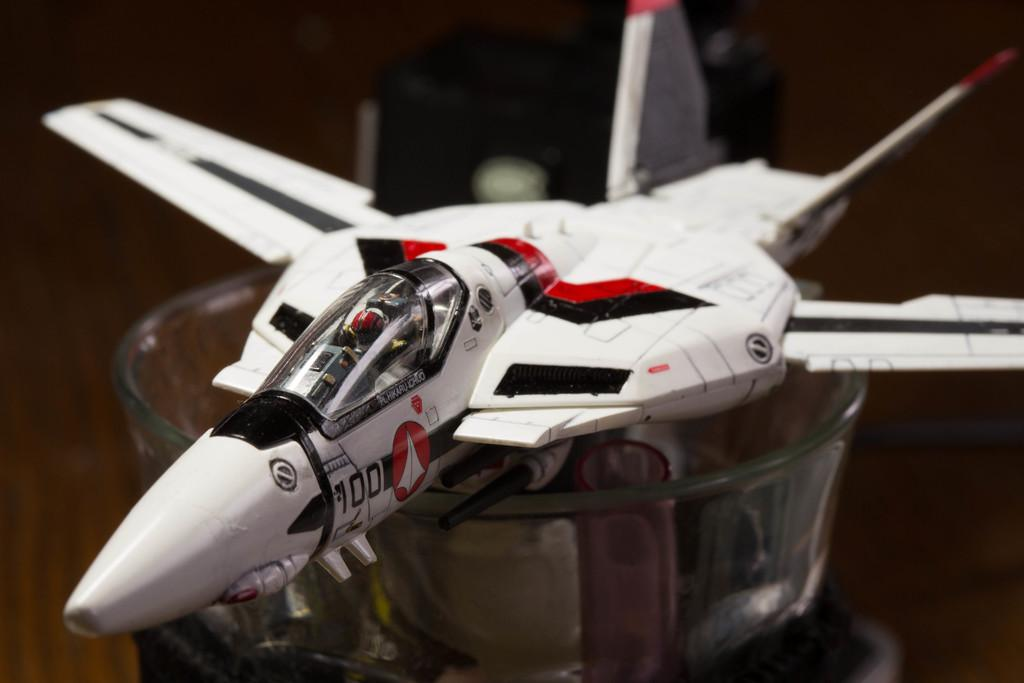What is the main subject in the center of the image? There is a toy airplane in the center of the image. What is located at the bottom of the image? There is a bowl and a wooden table at the bottom of the image. Can you describe the object in the background of the image? Unfortunately, the provided facts do not specify the object in the background of the image. How many men are visible in the image? There are no men present in the image. What color are the eyes of the person in the image? There is no person in the image, so there are no eyes to describe. 